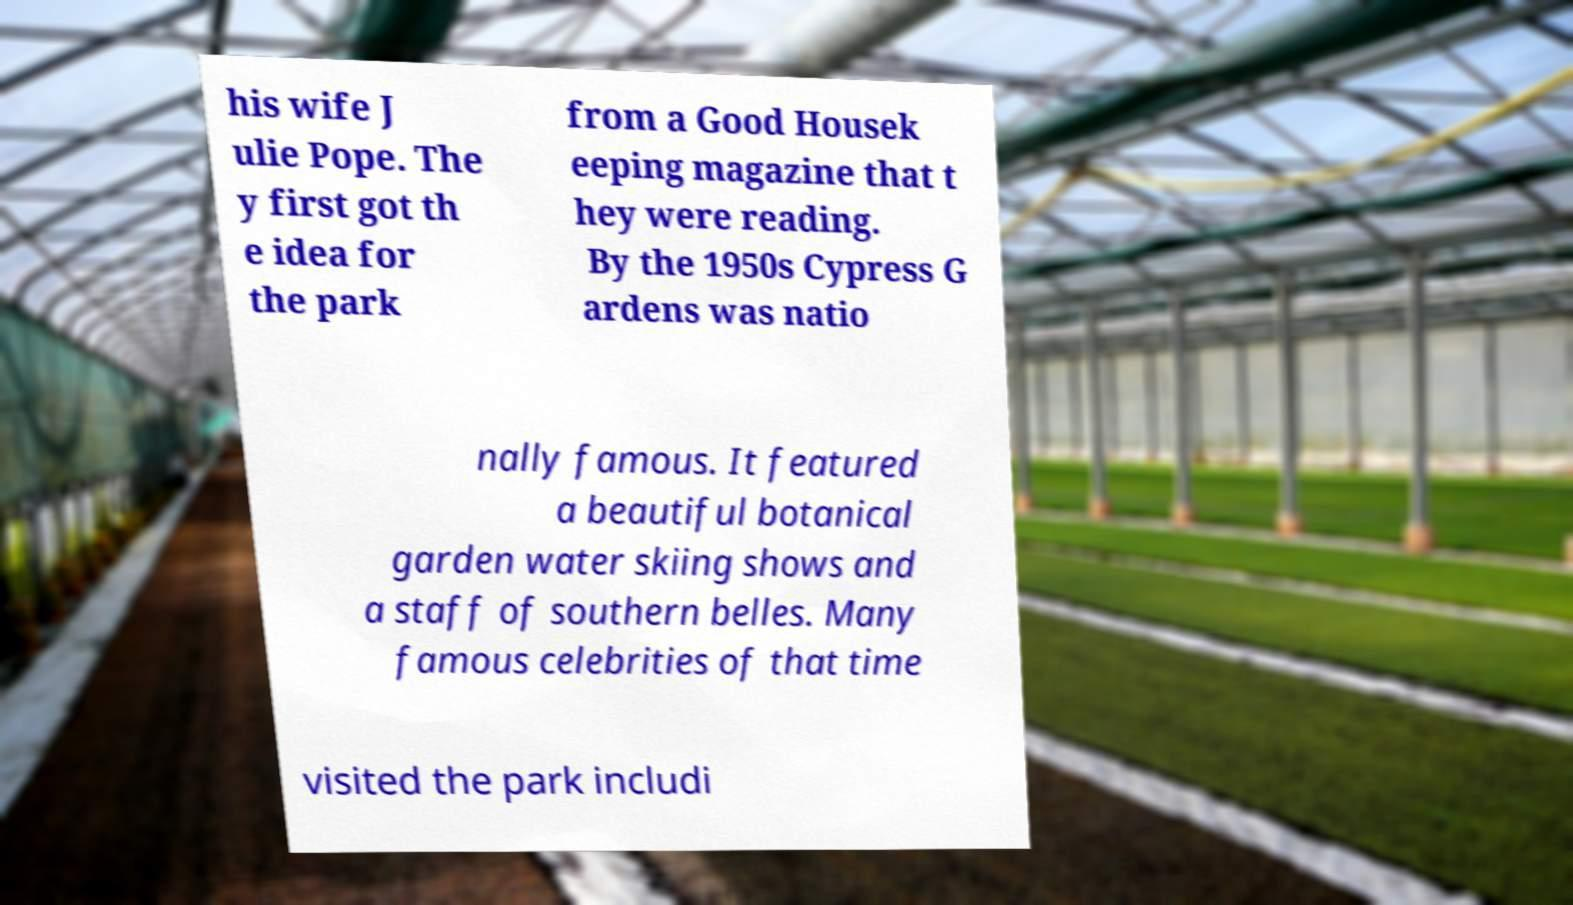There's text embedded in this image that I need extracted. Can you transcribe it verbatim? his wife J ulie Pope. The y first got th e idea for the park from a Good Housek eeping magazine that t hey were reading. By the 1950s Cypress G ardens was natio nally famous. It featured a beautiful botanical garden water skiing shows and a staff of southern belles. Many famous celebrities of that time visited the park includi 